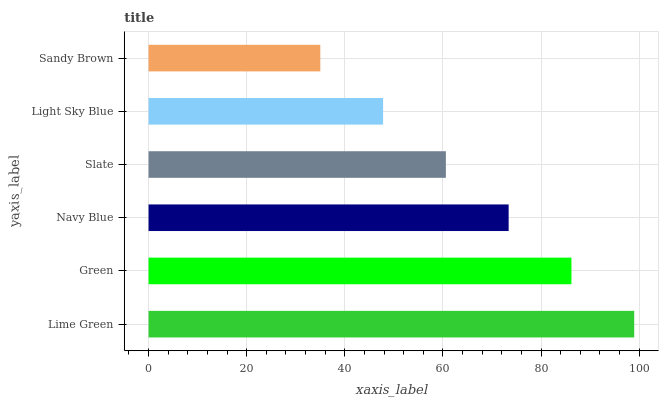Is Sandy Brown the minimum?
Answer yes or no. Yes. Is Lime Green the maximum?
Answer yes or no. Yes. Is Green the minimum?
Answer yes or no. No. Is Green the maximum?
Answer yes or no. No. Is Lime Green greater than Green?
Answer yes or no. Yes. Is Green less than Lime Green?
Answer yes or no. Yes. Is Green greater than Lime Green?
Answer yes or no. No. Is Lime Green less than Green?
Answer yes or no. No. Is Navy Blue the high median?
Answer yes or no. Yes. Is Slate the low median?
Answer yes or no. Yes. Is Green the high median?
Answer yes or no. No. Is Green the low median?
Answer yes or no. No. 